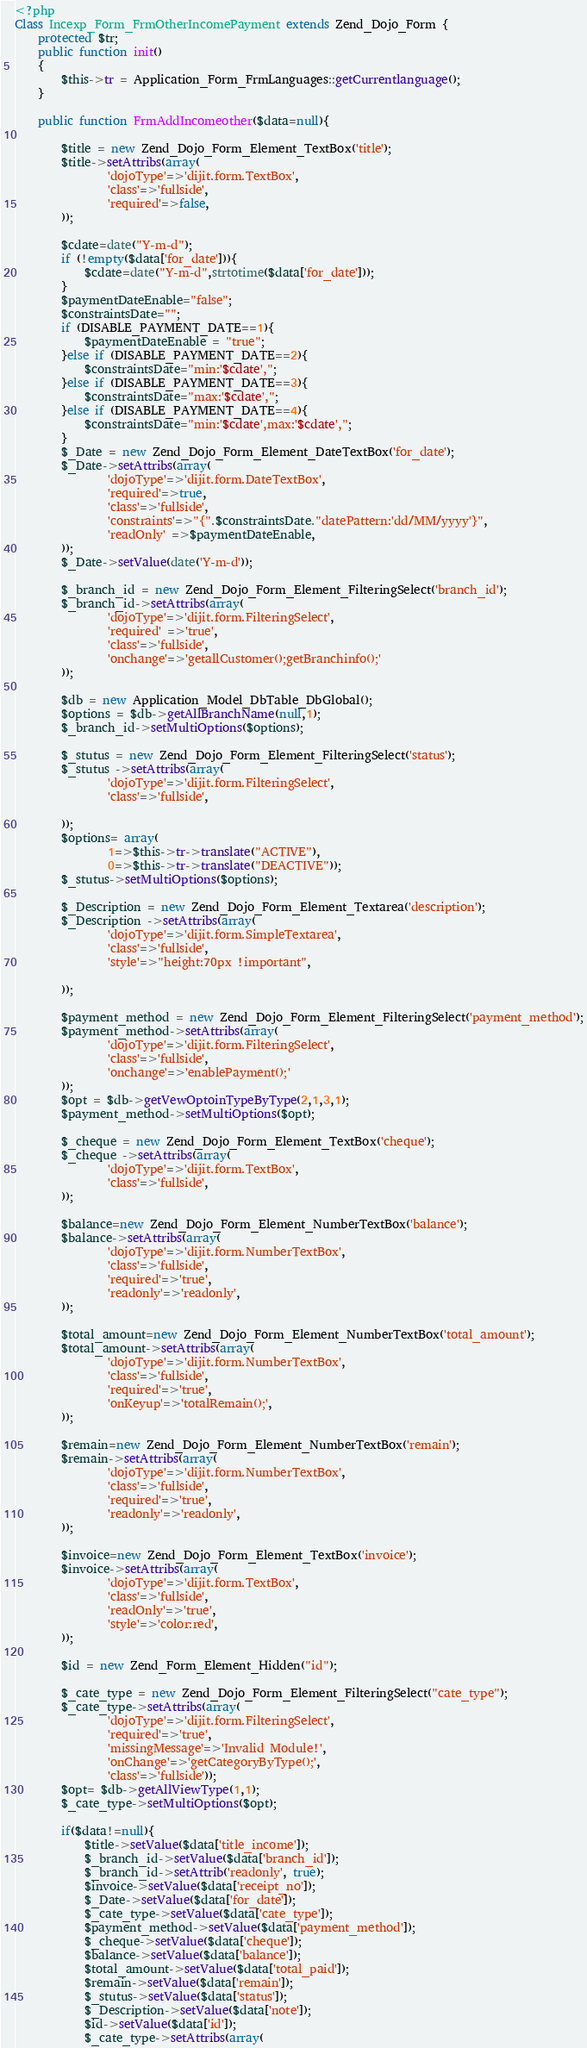<code> <loc_0><loc_0><loc_500><loc_500><_PHP_><?php 
Class Incexp_Form_FrmOtherIncomePayment extends Zend_Dojo_Form {
	protected $tr;
	public function init()
	{
		$this->tr = Application_Form_FrmLanguages::getCurrentlanguage();
	}
	
	public function FrmAddIncomeother($data=null){
	
		$title = new Zend_Dojo_Form_Element_TextBox('title');
		$title->setAttribs(array(
				'dojoType'=>'dijit.form.TextBox',
				'class'=>'fullside',
				'required'=>false,
		));
		
		$cdate=date("Y-m-d");
		if (!empty($data['for_date'])){
			$cdate=date("Y-m-d",strtotime($data['for_date']));
		}
		$paymentDateEnable="false";
		$constraintsDate="";
		if (DISABLE_PAYMENT_DATE==1){
			$paymentDateEnable = "true";
		}else if (DISABLE_PAYMENT_DATE==2){
			$constraintsDate="min:'$cdate',";
		}else if (DISABLE_PAYMENT_DATE==3){
			$constraintsDate="max:'$cdate',";
		}else if (DISABLE_PAYMENT_DATE==4){
			$constraintsDate="min:'$cdate',max:'$cdate',";
		}
		$_Date = new Zend_Dojo_Form_Element_DateTextBox('for_date');
		$_Date->setAttribs(array(
				'dojoType'=>'dijit.form.DateTextBox',
				'required'=>true,
				'class'=>'fullside',
				'constraints'=>"{".$constraintsDate."datePattern:'dd/MM/yyyy'}",
				'readOnly' =>$paymentDateEnable,
		));
		$_Date->setValue(date('Y-m-d'));
	
		$_branch_id = new Zend_Dojo_Form_Element_FilteringSelect('branch_id');
		$_branch_id->setAttribs(array(
				'dojoType'=>'dijit.form.FilteringSelect',
				'required' =>'true',
				'class'=>'fullside',
				'onchange'=>'getallCustomer();getBranchinfo();'
		));
	
		$db = new Application_Model_DbTable_DbGlobal();
		$options = $db->getAllBranchName(null,1);
		$_branch_id->setMultiOptions($options);
	
		$_stutus = new Zend_Dojo_Form_Element_FilteringSelect('status');
		$_stutus ->setAttribs(array(
				'dojoType'=>'dijit.form.FilteringSelect',
				'class'=>'fullside',
					
		));
		$options= array(
				1=>$this->tr->translate("ACTIVE"),
				0=>$this->tr->translate("DEACTIVE"));
		$_stutus->setMultiOptions($options);
	
		$_Description = new Zend_Dojo_Form_Element_Textarea('description');
		$_Description ->setAttribs(array(
				'dojoType'=>'dijit.form.SimpleTextarea',
				'class'=>'fullside',
				'style'=>"height:70px !important",
	
		));
		
		$payment_method = new Zend_Dojo_Form_Element_FilteringSelect('payment_method');
		$payment_method->setAttribs(array(
				'dojoType'=>'dijit.form.FilteringSelect',
				'class'=>'fullside',
				'onchange'=>'enablePayment();'
		));
		$opt = $db->getVewOptoinTypeByType(2,1,3,1);
		$payment_method->setMultiOptions($opt);
	
		$_cheque = new Zend_Dojo_Form_Element_TextBox('cheque');
		$_cheque ->setAttribs(array(
				'dojoType'=>'dijit.form.TextBox',
				'class'=>'fullside',
		));
		
		$balance=new Zend_Dojo_Form_Element_NumberTextBox('balance');
		$balance->setAttribs(array(
				'dojoType'=>'dijit.form.NumberTextBox',
				'class'=>'fullside',
				'required'=>'true',
				'readonly'=>'readonly',
		));
		
		$total_amount=new Zend_Dojo_Form_Element_NumberTextBox('total_amount');
		$total_amount->setAttribs(array(
				'dojoType'=>'dijit.form.NumberTextBox',
				'class'=>'fullside',
				'required'=>'true',
				'onKeyup'=>'totalRemain();',
		));
	
		$remain=new Zend_Dojo_Form_Element_NumberTextBox('remain');
		$remain->setAttribs(array(
				'dojoType'=>'dijit.form.NumberTextBox',
				'class'=>'fullside',
				'required'=>'true',
				'readonly'=>'readonly',
		));
		
		$invoice=new Zend_Dojo_Form_Element_TextBox('invoice');
		$invoice->setAttribs(array(
				'dojoType'=>'dijit.form.TextBox',
				'class'=>'fullside',
				'readOnly'=>'true',
				'style'=>'color:red',
		));
	
		$id = new Zend_Form_Element_Hidden("id");
		
		$_cate_type = new Zend_Dojo_Form_Element_FilteringSelect("cate_type");
		$_cate_type->setAttribs(array(
				'dojoType'=>'dijit.form.FilteringSelect',
				'required'=>'true',
				'missingMessage'=>'Invalid Module!',
				'onChange'=>'getCategoryByType();',
				'class'=>'fullside'));
		$opt= $db->getAllViewType(1,1);
		$_cate_type->setMultiOptions($opt);
	
		if($data!=null){
			$title->setValue($data['title_income']);
			$_branch_id->setValue($data['branch_id']);
			$_branch_id->setAttrib('readonly', true);
			$invoice->setValue($data['receipt_no']);
			$_Date->setValue($data['for_date']);
			$_cate_type->setValue($data['cate_type']);
			$payment_method->setValue($data['payment_method']);
			$_cheque->setValue($data['cheque']);
			$balance->setValue($data['balance']);
			$total_amount->setValue($data['total_paid']);
			$remain->setValue($data['remain']);
			$_stutus->setValue($data['status']);
			$_Description->setValue($data['note']);
			$id->setValue($data['id']);
			$_cate_type->setAttribs(array(</code> 